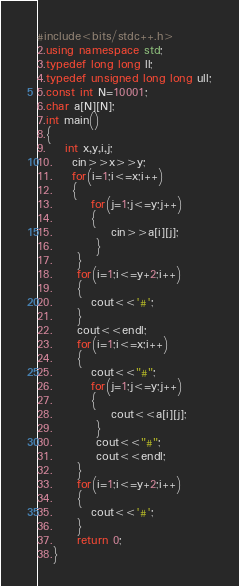Convert code to text. <code><loc_0><loc_0><loc_500><loc_500><_C++_>#include<bits/stdc++.h>
2.using namespace std;
3.typedef long long ll;
4.typedef unsigned long long ull;
5.const int N=10001;
6.char a[N][N];
7.int main()
8.{
9. 	int x,y,i,j;
10. 	cin>>x>>y;
11. 	for(i=1;i<=x;i++)
12. 	{
13. 		for(j=1;j<=y;j++)
14. 		{
15. 			cin>>a[i][j];
16.		 }
17.	 }
18.	 for(i=1;i<=y+2;i++)
19.	 {
20.	 	cout<<'#'; 
21.	 }
22.	 cout<<endl;
23.	 for(i=1;i<=x;i++)
24.	 {
25.	 	cout<<"#";
26.	 	for(j=1;j<=y;j++)
27.	 	{
28.	 		cout<<a[i][j];
29.		 }
30.		 cout<<"#";
31.		 cout<<endl;
32.	 }
33.	 for(i=1;i<=y+2;i++)
34.	 {
35.	 	cout<<'#'; 
36.	 }
37.	 return 0;
38.}
</code> 